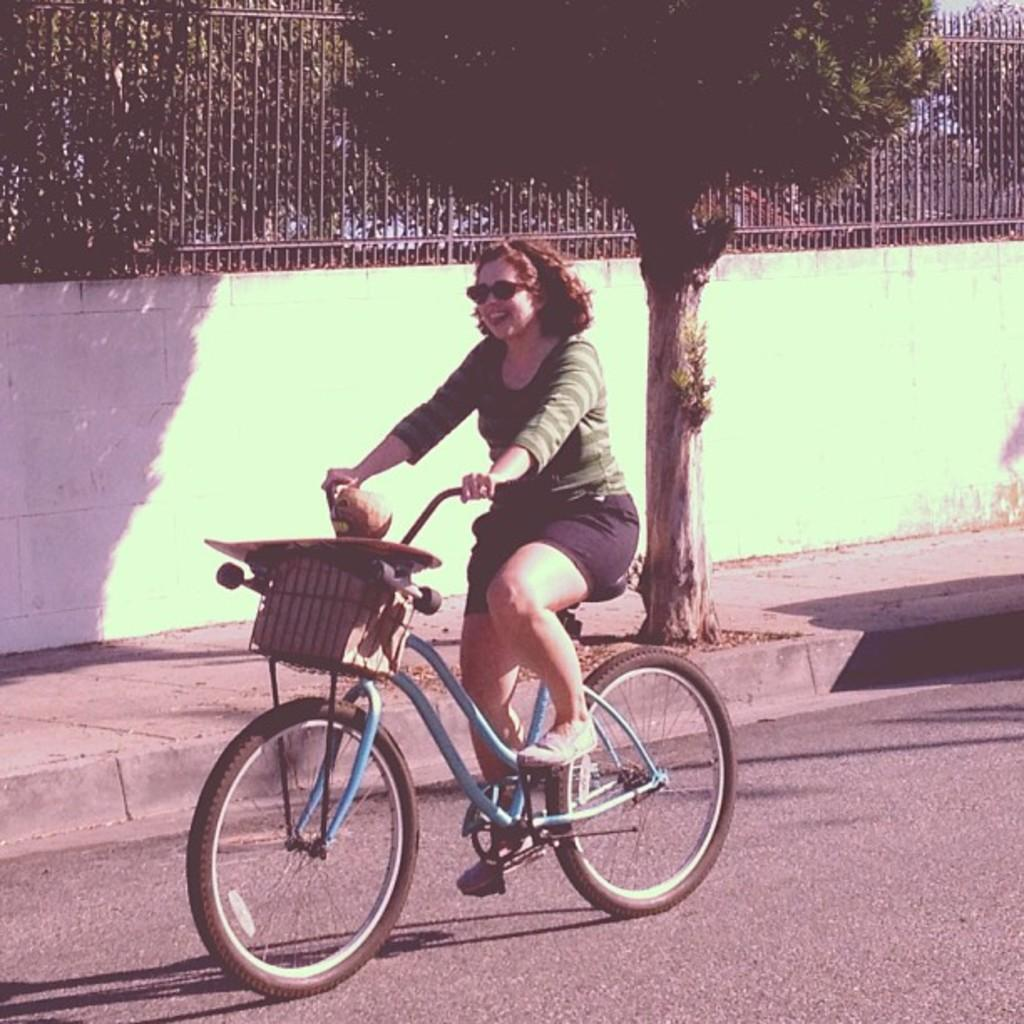What is the person in the image doing? The person is sitting and riding a bicycle on the road. What can be seen behind the person? There is a tree visible behind the person. What structures are present in the image? There is a fence and a wall visible in the image. What is visible beyond the fence? Trees are visible beyond the fence. What channel is the person watching while riding the bicycle? There is no indication in the image that the person is watching a channel, as they are focused on riding the bicycle. 